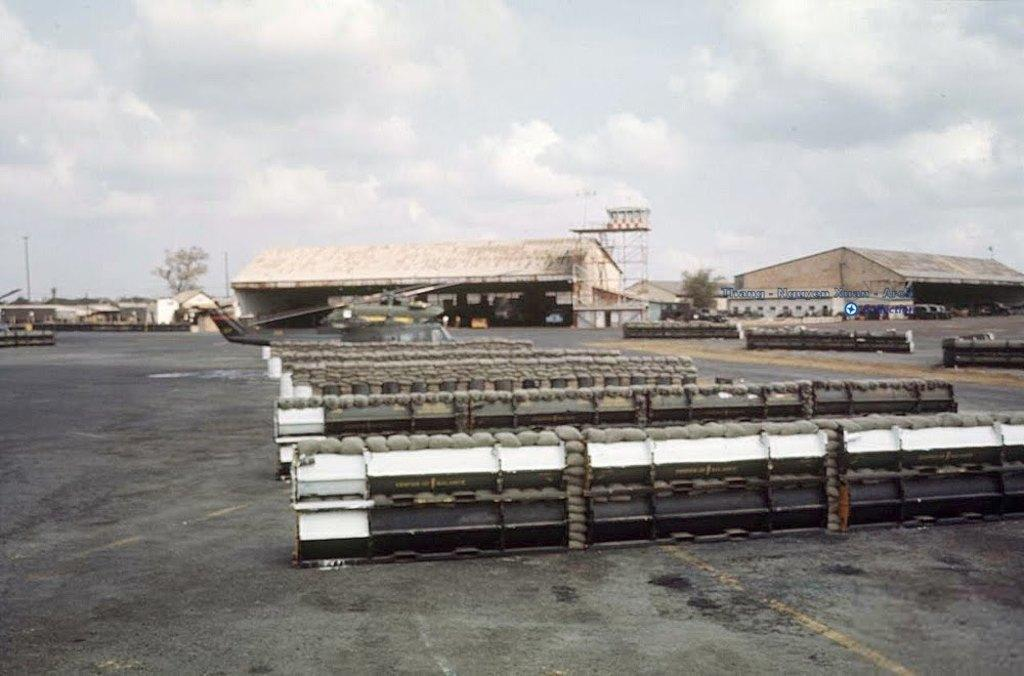What type of structures can be seen in the image? There are sheds in the image. What natural elements are present in the image? There are trees in the image. What man-made objects can be seen in the image? There are poles in the image. What is on the road in the image? There are pallets and other objects on the road in the image. What is visible in the sky at the top of the image? There are clouds in the sky at the top of the image. Where is the meeting taking place in the image? There is no meeting present in the image. What type of cloth is draped over the sheds in the image? There is no cloth present in the image; it only shows sheds, trees, poles, pallets, other objects, and clouds. 